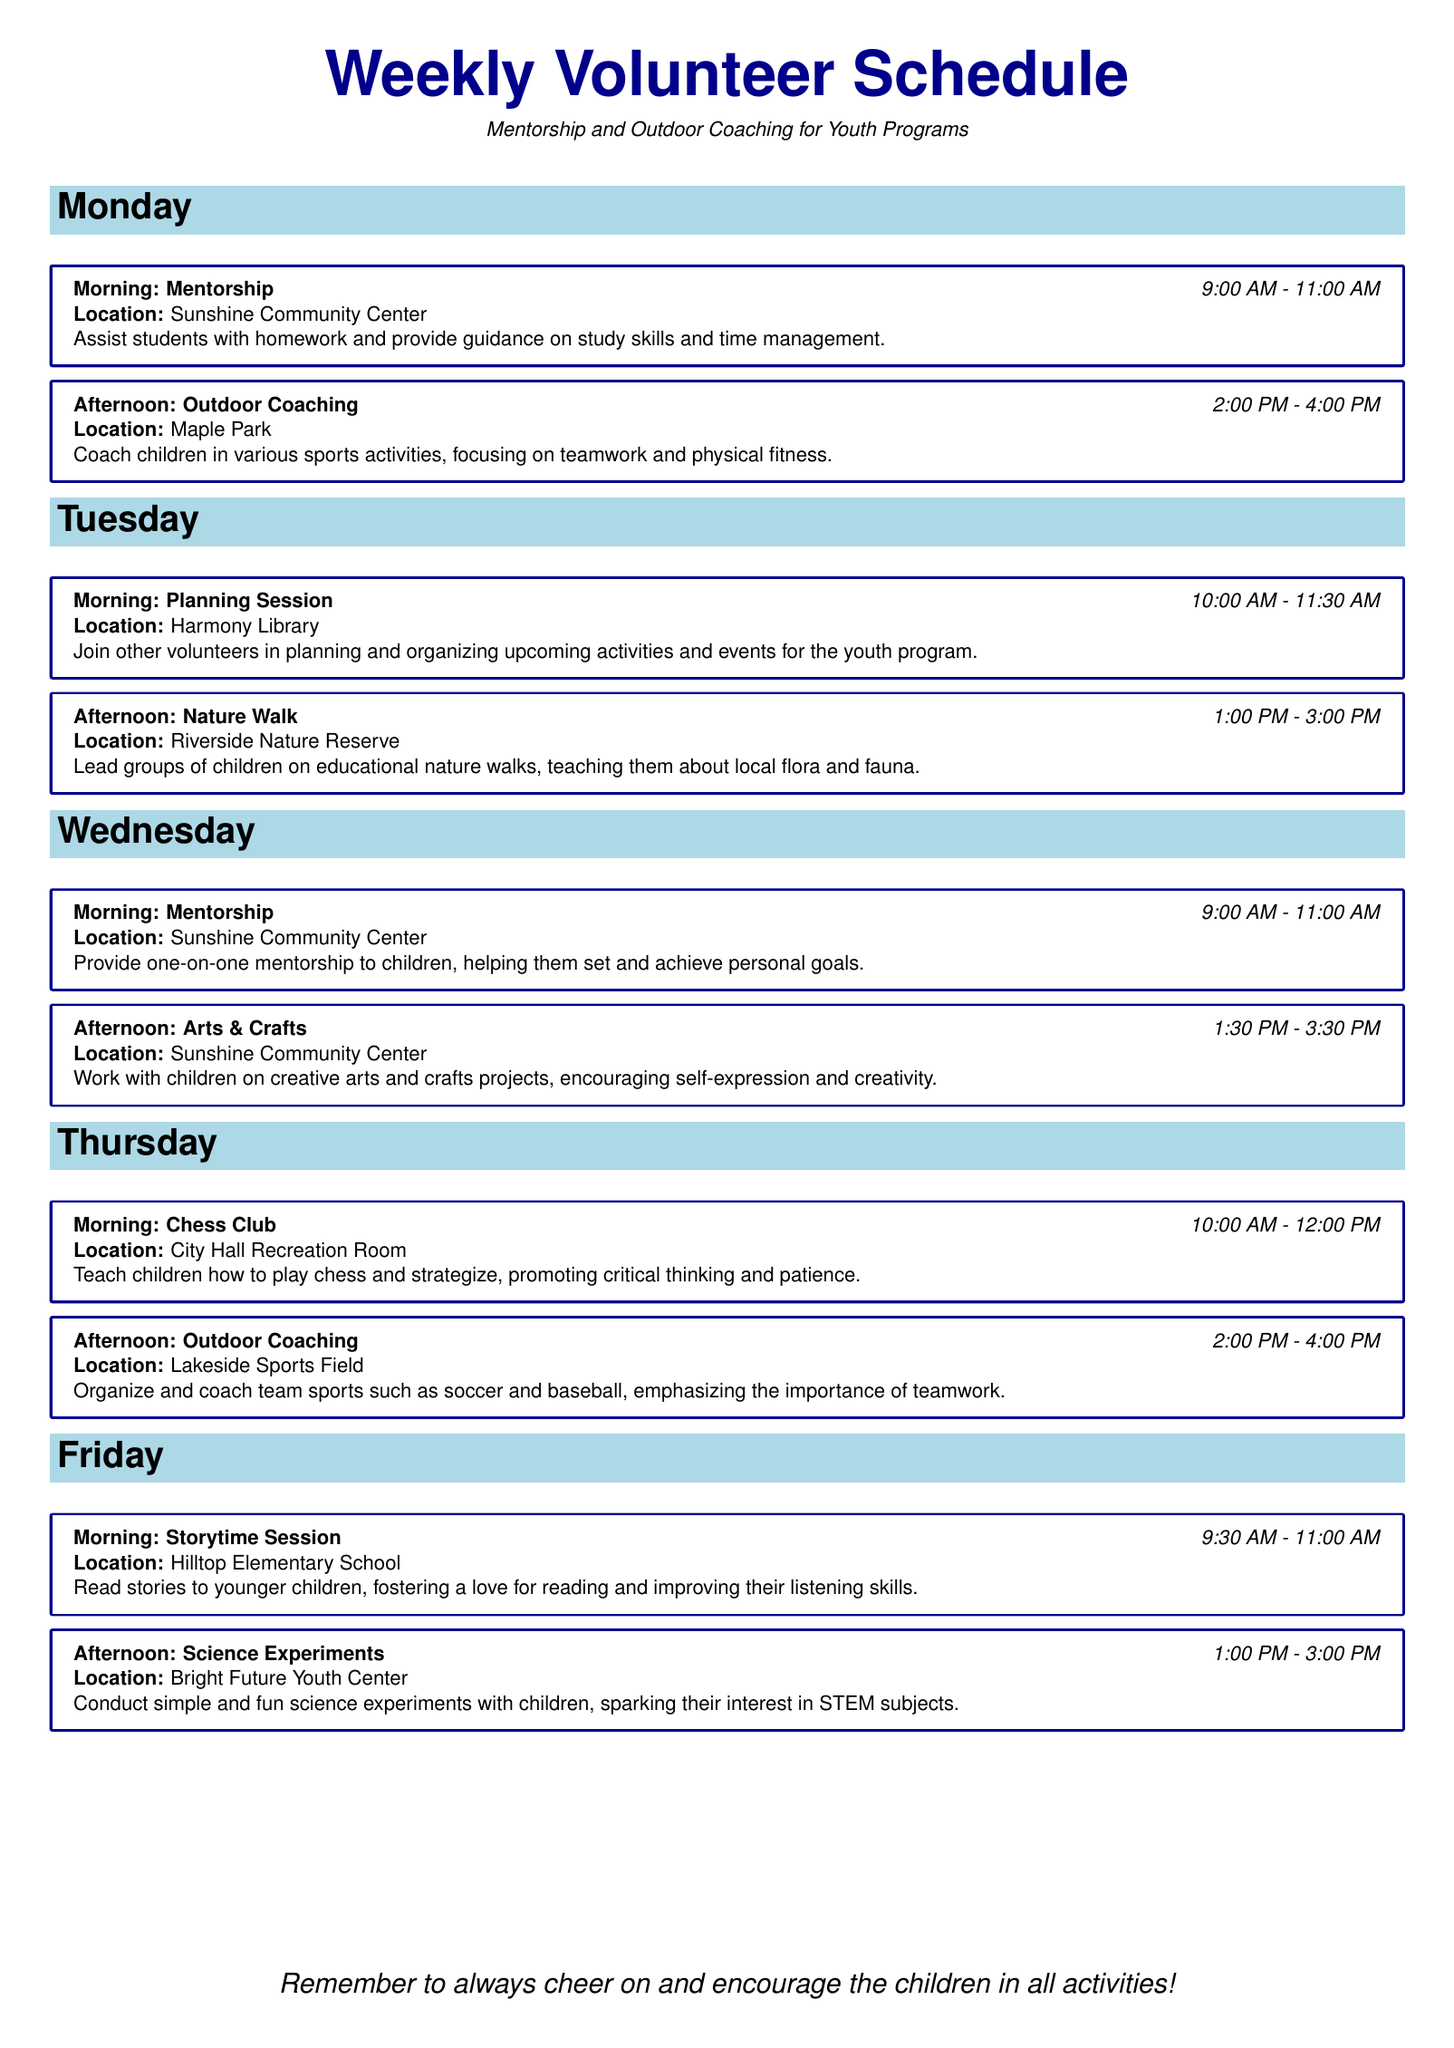What activities occur on Monday morning? The document lists the activity for Monday morning as mentorship, which involves assisting with homework and study skills.
Answer: Mentorship What time does the Nature Walk start on Tuesday? According to the schedule on Tuesday, the Nature Walk begins at 1:00 PM.
Answer: 1:00 PM Where is the Storytime Session held? The Storytime Session is located at Hilltop Elementary School.
Answer: Hilltop Elementary School What is the focus of the Outdoor Coaching on Thursday? The Thursday Outdoor Coaching emphasizes teamwork through team sports like soccer and baseball.
Answer: Teamwork How long is the Chess Club session on Thursday? The Chess Club session lasts for 2 hours, from 10:00 AM to 12:00 PM, as stated in the document.
Answer: 2 hours What type of projects are done during the Arts & Crafts session? The focus of the Arts & Crafts session is on creative arts and crafts projects that encourage self-expression.
Answer: Creative arts and crafts projects How many different locations are mentioned in the document for activities? The document lists 5 different locations for the scheduled activities.
Answer: 5 What is the main goal of the mentorship program on Wednesday? The main goal of the mentorship program is to help children set and achieve personal goals.
Answer: Personal goals When does the Friday afternoon Science Experiments session end? The Friday afternoon Science Experiments session ends at 3:00 PM, as outlined in the schedule.
Answer: 3:00 PM What type of activities does the weekly volunteer schedule focus on? The weekly volunteer schedule focuses on mentorship and outdoor coaching for youth programs.
Answer: Mentorship and outdoor coaching 